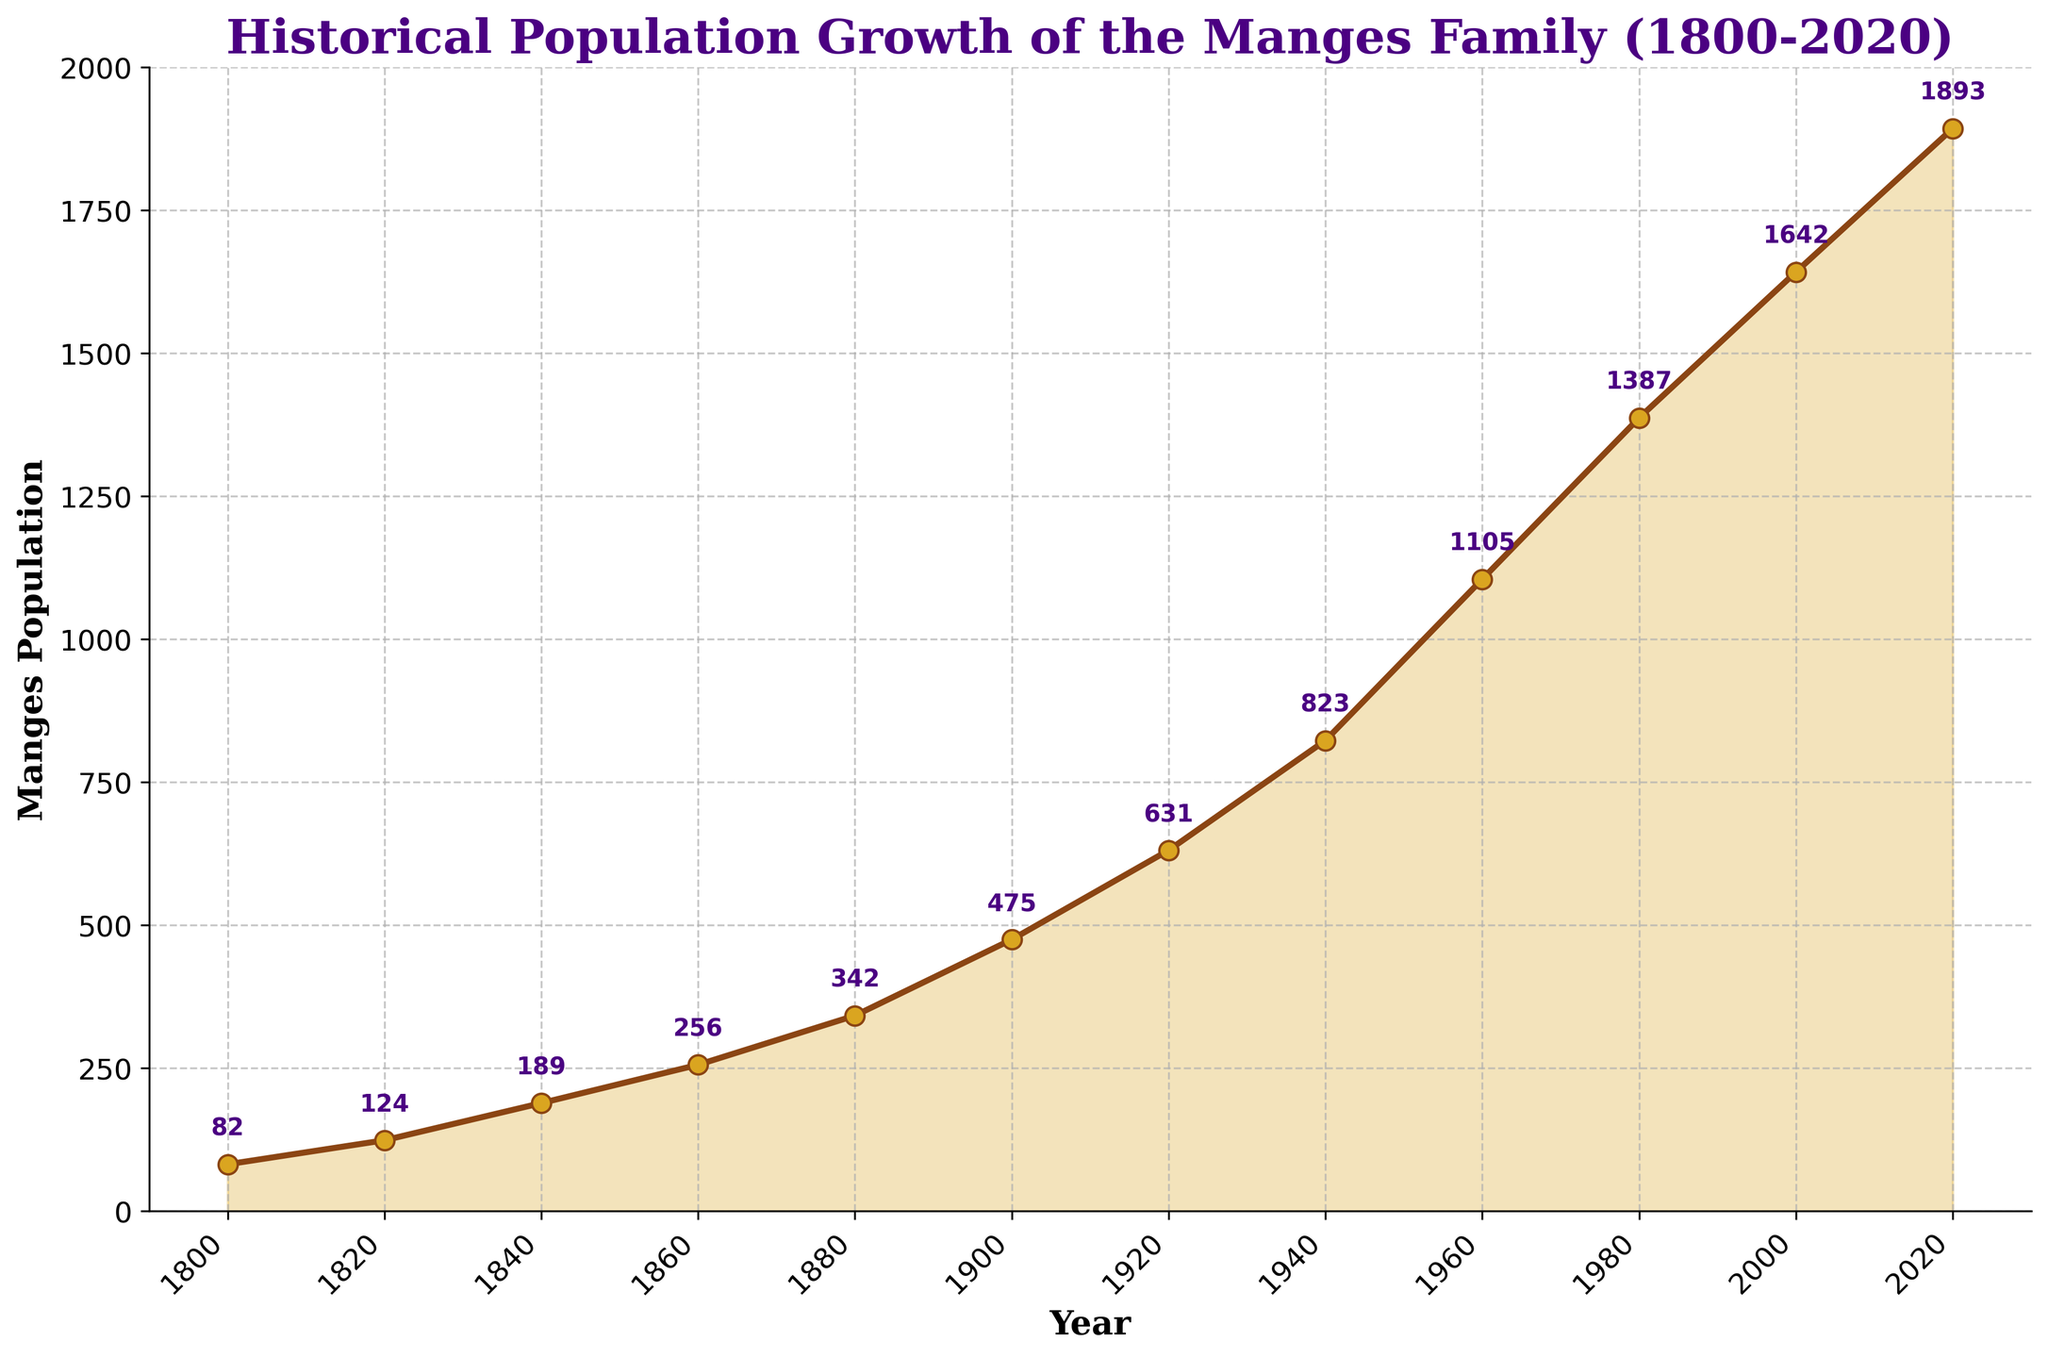What's the overall trend of the Manges family population from 1800 to 2020? The line chart visually shows that the population of the Manges family has been steadily increasing from 1800 to 2020, forming an upward-sloping line.
Answer: Increasing By how much did the Manges population grow between 1800 and 2020? The population in 1800 was 82 and in 2020 it was 1893. Subtracting the 1800 population from the 2020 population gives 1893 - 82 = 1811.
Answer: 1811 Which two consecutive decades saw the highest population increase? Looking at the steepness of the line and reviewing the annotated values, the period between 1940 (823) and 1960 (1105) shows the largest increase. The difference is 1105 - 823 = 282.
Answer: 1940-1960 Compare the population of the Manges family in the year 1880 and 1920. What can you say about the growth rate during this period? In 1880, the population was 342, and in 1920, it was 631. The increase is 631 - 342 = 289 over 40 years, indicating a moderate growth rate during these years.
Answer: Moderate growth rate What is the average population of the Manges family over the entire period from 1800 to 2020? Sum the populations for all the years provided and divide by the number of years. (82+124+189+256+342+475+631+823+1105+1387+1642+1893) / 12 ≈ 745.75
Answer: 746 Was there any period where the population decrease was visible in the chart? Reviewing the line chart, there is no visible downward slope in any period, indicating that there was no period where the population decreased.
Answer: No Around what year did the population exceed 1000 for the first time, and by how much? The population exceeded 1000 for the first time in 1960, with a record of 1105. The amount exceeded is 1105 - 1000 = 105.
Answer: 1960, 105 How does the population growth between 2000 to 2020 compare to the growth between 1800 to 1820? From 2000 to 2020, the increase was 1893 - 1642 = 251. From 1800 to 1820, the increase was 124 - 82 = 42. The growth was much higher in the more recent period.
Answer: Higher between 2000-2020 Looking at the annotations, which decades’ populations are closest in value? The populations in 1900 (475) and 1920 (631) are closest in value when comparing the differences.
Answer: 1900 and 1920 Based on the pattern of lines, describe the rate of population growth in the later years (from 1940 onwards). The line becomes steeper from 1940 onwards, indicating that the rate of population growth accelerated during these years, especially between 1940 and 1960.
Answer: Accelerated rate 